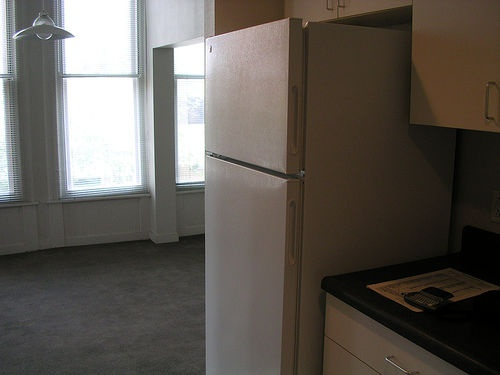Describe the objects in this image and their specific colors. I can see a refrigerator in white, black, gray, and darkgray tones in this image. 